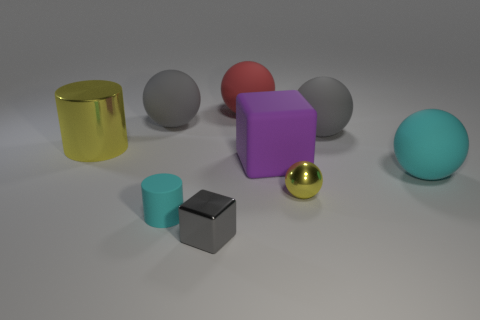Is there anything else that has the same size as the gray shiny thing? Yes, the small cyan-colored cylinder appears to be of similar size to the gray shiny sphere. 